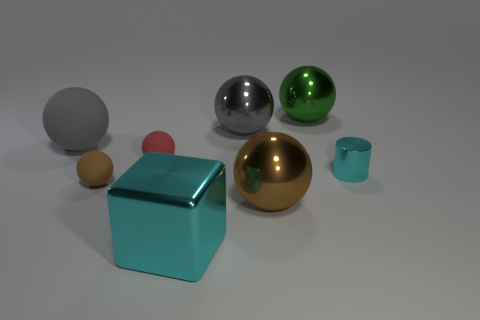There is a object that is the same color as the big shiny block; what shape is it?
Your answer should be compact. Cylinder. How many spheres are either big yellow metallic things or big gray metallic things?
Keep it short and to the point. 1. There is a matte sphere that is the same size as the brown metal ball; what is its color?
Keep it short and to the point. Gray. There is a small thing that is in front of the cyan object right of the green sphere; what is its shape?
Offer a terse response. Sphere. There is a shiny object behind the gray metal object; does it have the same size as the cyan shiny block?
Your response must be concise. Yes. How many other things are made of the same material as the large green ball?
Provide a short and direct response. 4. What number of gray objects are small cubes or big metallic objects?
Ensure brevity in your answer.  1. There is another shiny object that is the same color as the small metal thing; what is its size?
Your answer should be compact. Large. There is a large shiny cube; what number of tiny brown things are on the right side of it?
Your response must be concise. 0. What is the size of the cyan object that is in front of the tiny matte thing that is on the left side of the small ball behind the tiny cylinder?
Offer a very short reply. Large. 